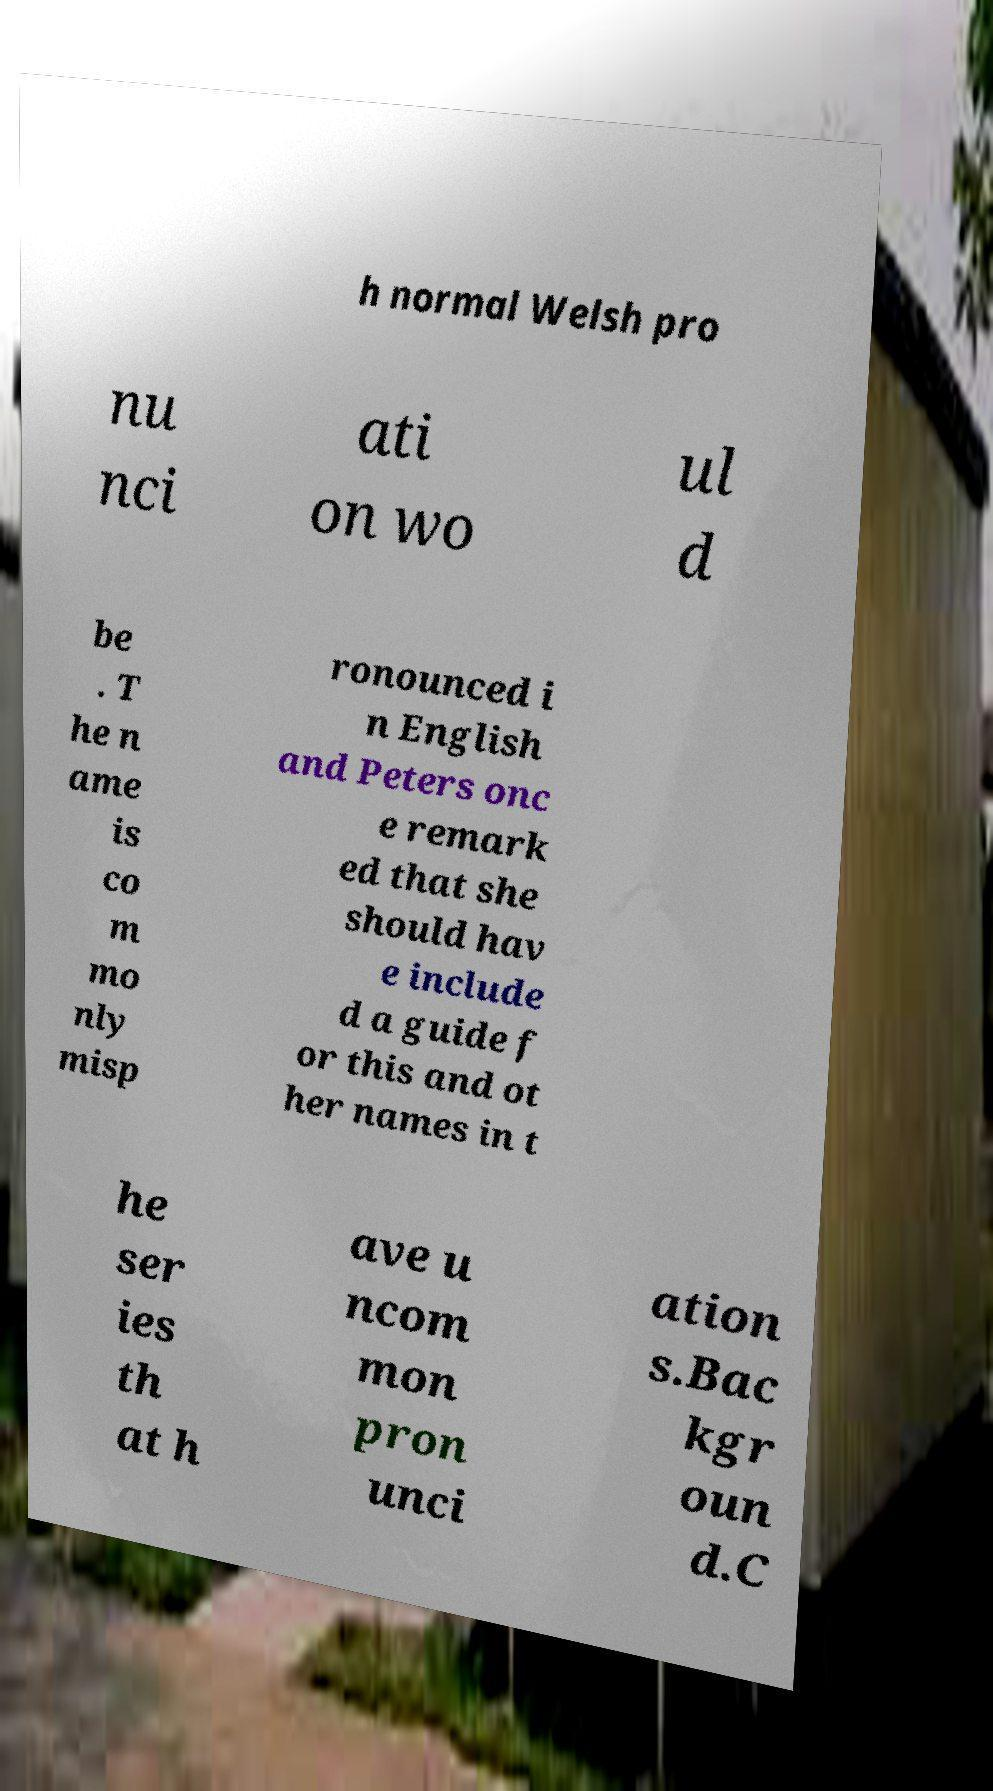Could you extract and type out the text from this image? h normal Welsh pro nu nci ati on wo ul d be . T he n ame is co m mo nly misp ronounced i n English and Peters onc e remark ed that she should hav e include d a guide f or this and ot her names in t he ser ies th at h ave u ncom mon pron unci ation s.Bac kgr oun d.C 